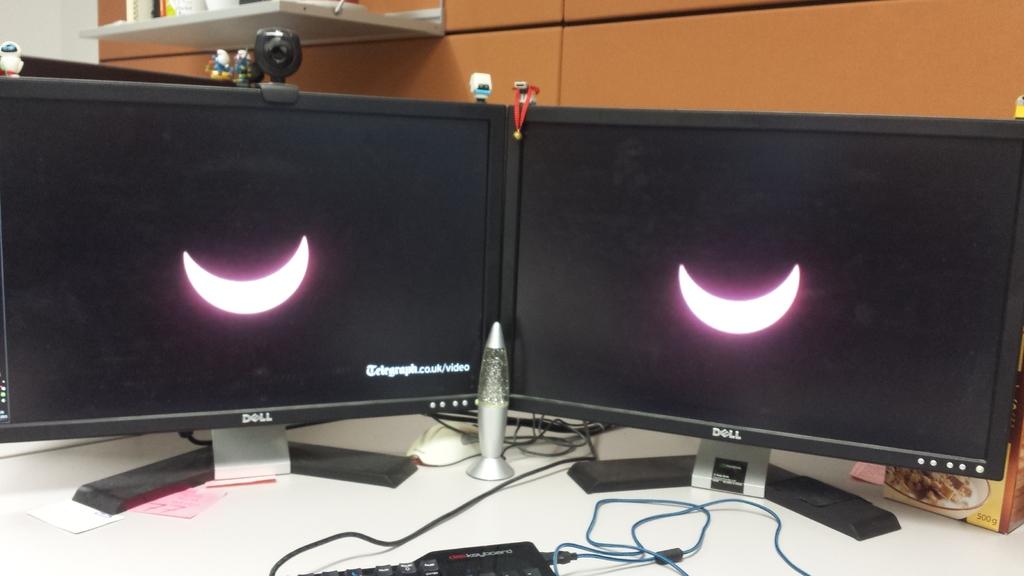What is the brand of these montiors?
Your answer should be compact. Dell. What link is shown on the monitor?
Provide a succinct answer. Telegraph.co.uk/video. 